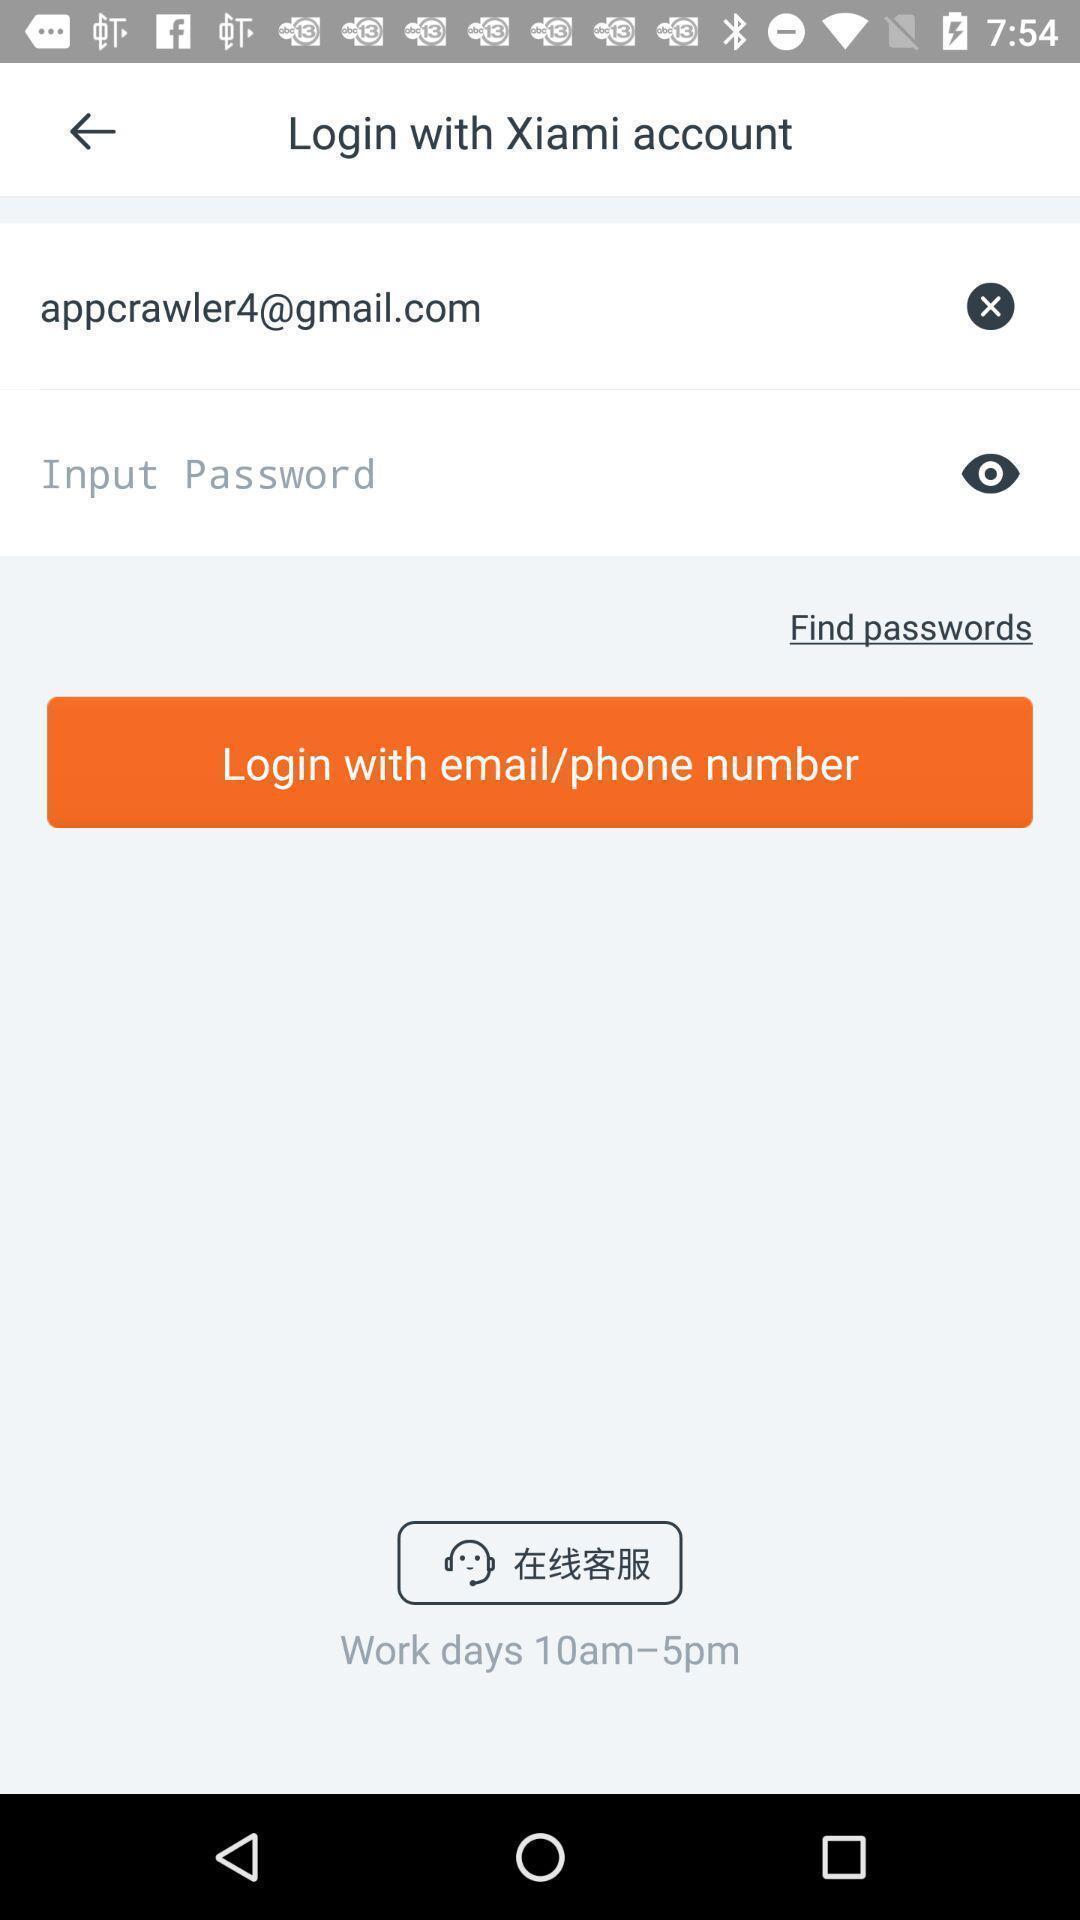Please provide a description for this image. Page showing about login option. 